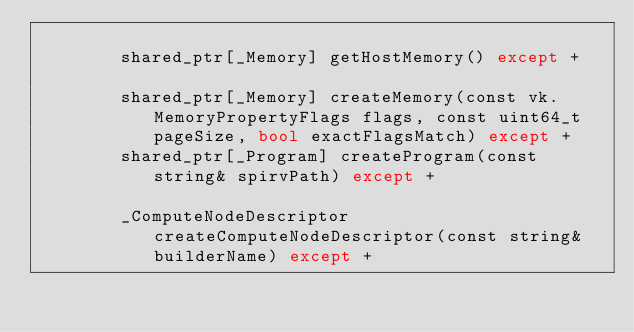Convert code to text. <code><loc_0><loc_0><loc_500><loc_500><_Cython_>
        shared_ptr[_Memory] getHostMemory() except +

        shared_ptr[_Memory] createMemory(const vk.MemoryPropertyFlags flags, const uint64_t pageSize, bool exactFlagsMatch) except +
        shared_ptr[_Program] createProgram(const string& spirvPath) except +

        _ComputeNodeDescriptor createComputeNodeDescriptor(const string& builderName) except +</code> 